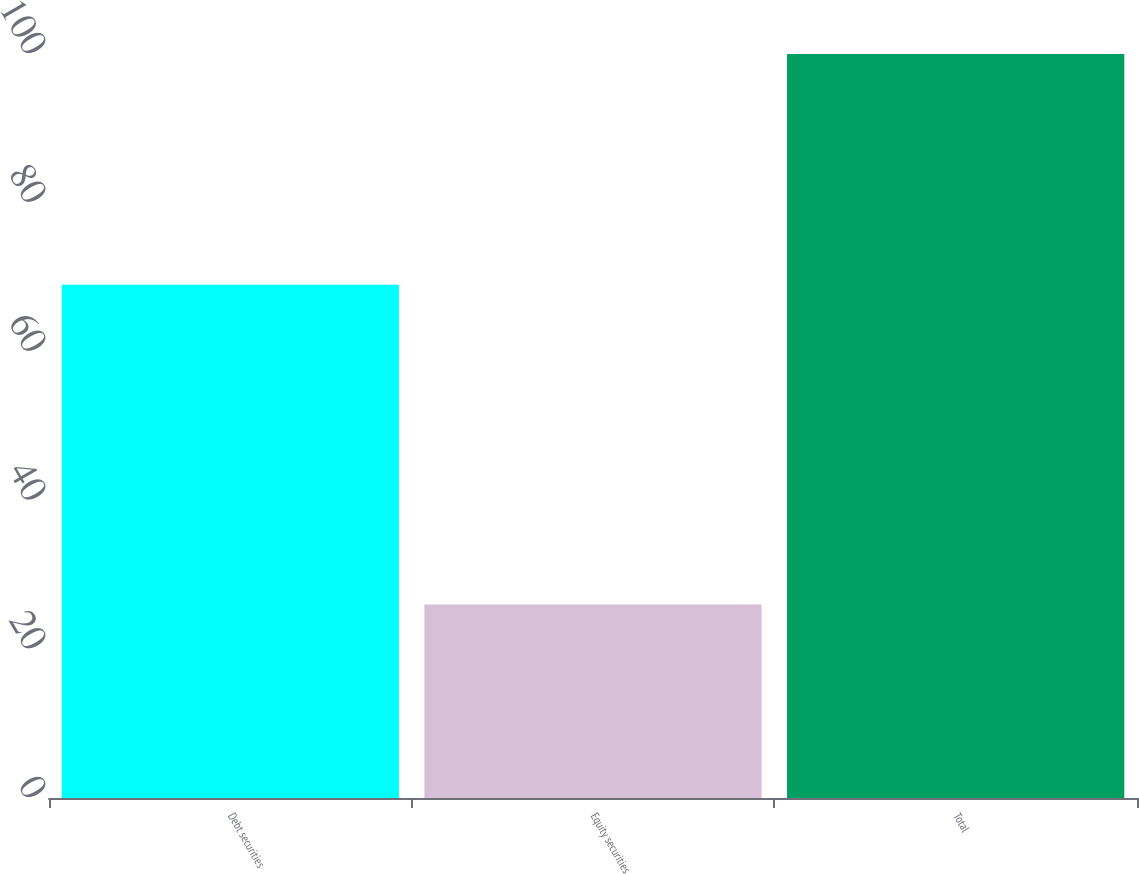<chart> <loc_0><loc_0><loc_500><loc_500><bar_chart><fcel>Debt securities<fcel>Equity securities<fcel>Total<nl><fcel>69<fcel>26<fcel>100<nl></chart> 